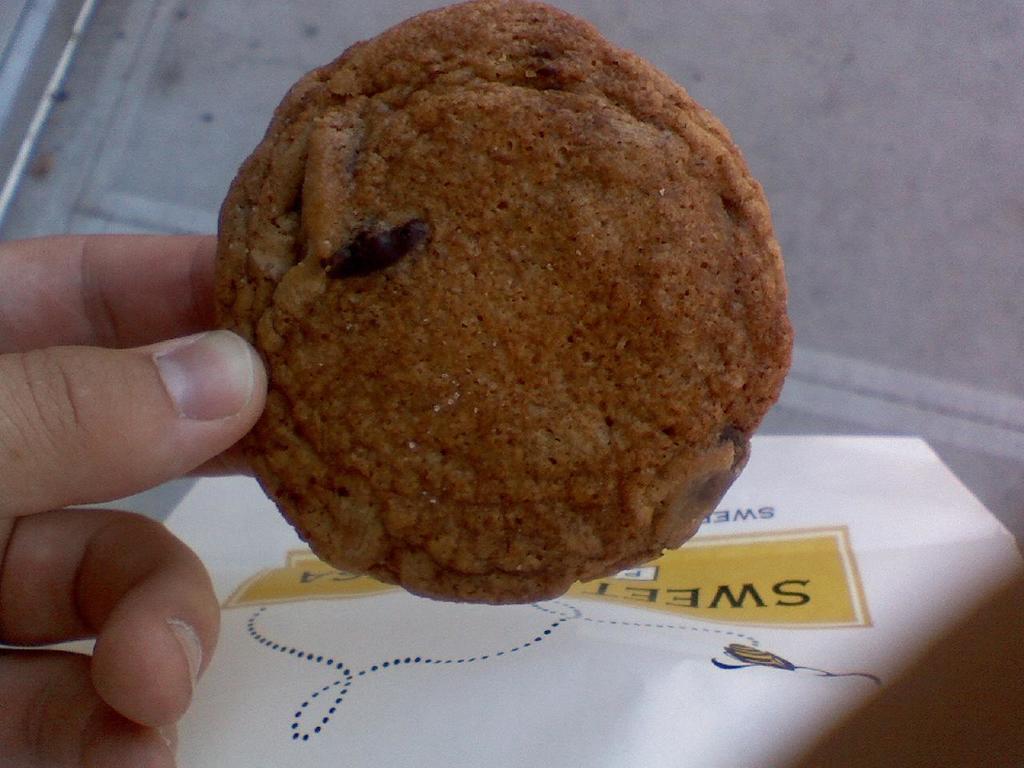Describe this image in one or two sentences. In this image we can see a person's hand holding a food item and there is a paper with some text. 